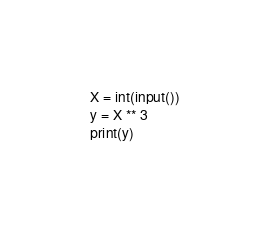Convert code to text. <code><loc_0><loc_0><loc_500><loc_500><_Python_>X = int(input())
y = X ** 3
print(y)
</code> 